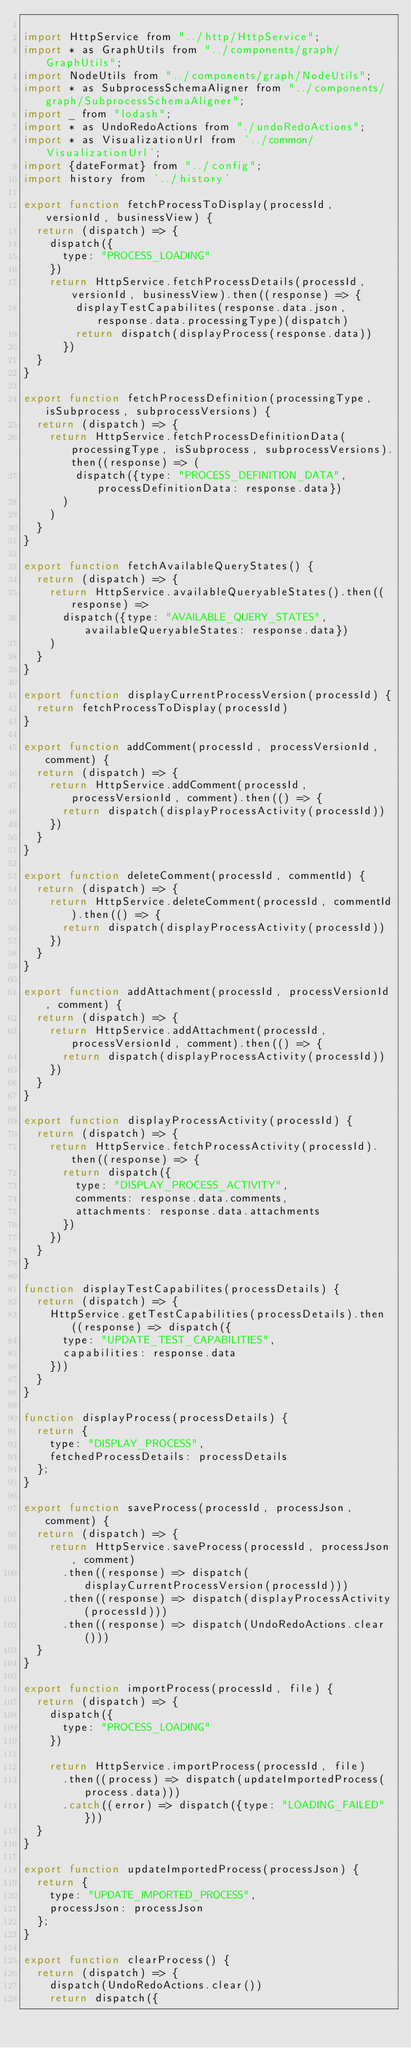Convert code to text. <code><loc_0><loc_0><loc_500><loc_500><_JavaScript_>
import HttpService from "../http/HttpService";
import * as GraphUtils from "../components/graph/GraphUtils";
import NodeUtils from "../components/graph/NodeUtils";
import * as SubprocessSchemaAligner from "../components/graph/SubprocessSchemaAligner";
import _ from "lodash";
import * as UndoRedoActions from "./undoRedoActions";
import * as VisualizationUrl from '../common/VisualizationUrl';
import {dateFormat} from "../config";
import history from '../history'

export function fetchProcessToDisplay(processId, versionId, businessView) {
  return (dispatch) => {
    dispatch({
      type: "PROCESS_LOADING"
    })
    return HttpService.fetchProcessDetails(processId, versionId, businessView).then((response) => {
        displayTestCapabilites(response.data.json, response.data.processingType)(dispatch)
        return dispatch(displayProcess(response.data))
      })
  }
}

export function fetchProcessDefinition(processingType, isSubprocess, subprocessVersions) {
  return (dispatch) => {
    return HttpService.fetchProcessDefinitionData(processingType, isSubprocess, subprocessVersions).then((response) => (
        dispatch({type: "PROCESS_DEFINITION_DATA", processDefinitionData: response.data})
      )
    )
  }
}

export function fetchAvailableQueryStates() {
  return (dispatch) => {
    return HttpService.availableQueryableStates().then((response) =>
      dispatch({type: "AVAILABLE_QUERY_STATES", availableQueryableStates: response.data})
    )
  }
}

export function displayCurrentProcessVersion(processId) {
  return fetchProcessToDisplay(processId)
}

export function addComment(processId, processVersionId, comment) {
  return (dispatch) => {
    return HttpService.addComment(processId, processVersionId, comment).then(() => {
      return dispatch(displayProcessActivity(processId))
    })
  }
}

export function deleteComment(processId, commentId) {
  return (dispatch) => {
    return HttpService.deleteComment(processId, commentId).then(() => {
      return dispatch(displayProcessActivity(processId))
    })
  }
}

export function addAttachment(processId, processVersionId, comment) {
  return (dispatch) => {
    return HttpService.addAttachment(processId, processVersionId, comment).then(() => {
      return dispatch(displayProcessActivity(processId))
    })
  }
}

export function displayProcessActivity(processId) {
  return (dispatch) => {
    return HttpService.fetchProcessActivity(processId).then((response) => {
      return dispatch({
        type: "DISPLAY_PROCESS_ACTIVITY",
        comments: response.data.comments,
        attachments: response.data.attachments
      })
    })
  }
}

function displayTestCapabilites(processDetails) {
  return (dispatch) => {
    HttpService.getTestCapabilities(processDetails).then((response) => dispatch({
      type: "UPDATE_TEST_CAPABILITIES",
      capabilities: response.data
    }))
  }
}

function displayProcess(processDetails) {
  return {
    type: "DISPLAY_PROCESS",
    fetchedProcessDetails: processDetails
  };
}

export function saveProcess(processId, processJson, comment) {
  return (dispatch) => {
    return HttpService.saveProcess(processId, processJson, comment)
      .then((response) => dispatch(displayCurrentProcessVersion(processId)))
      .then((response) => dispatch(displayProcessActivity(processId)))
      .then((response) => dispatch(UndoRedoActions.clear()))
  }
}

export function importProcess(processId, file) {
  return (dispatch) => {
    dispatch({
      type: "PROCESS_LOADING"
    })

    return HttpService.importProcess(processId, file)
      .then((process) => dispatch(updateImportedProcess(process.data)))
      .catch((error) => dispatch({type: "LOADING_FAILED"}))
  }
}

export function updateImportedProcess(processJson) {
  return {
    type: "UPDATE_IMPORTED_PROCESS",
    processJson: processJson
  };
}

export function clearProcess() {
  return (dispatch) => {
    dispatch(UndoRedoActions.clear())
    return dispatch({</code> 